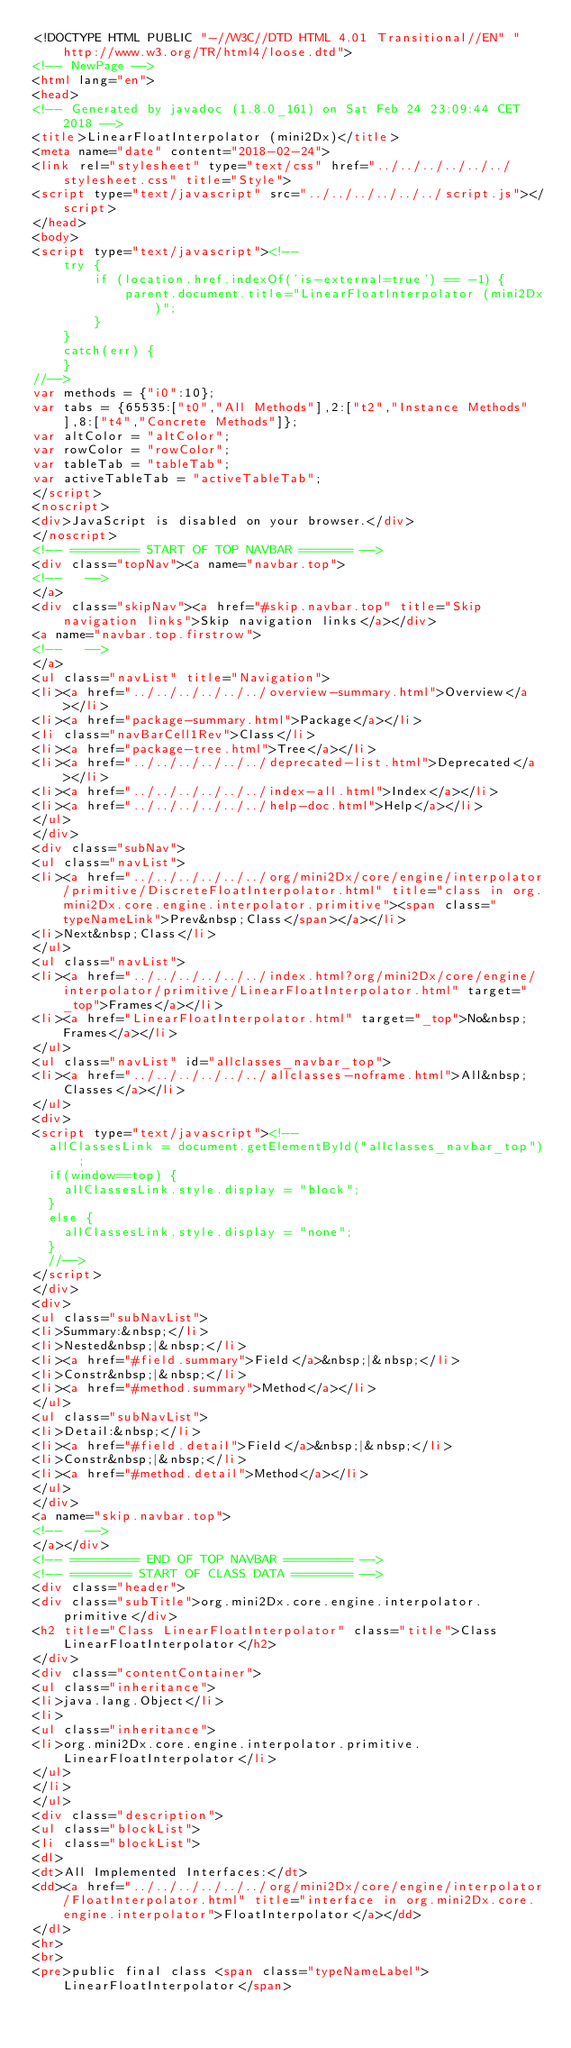<code> <loc_0><loc_0><loc_500><loc_500><_HTML_><!DOCTYPE HTML PUBLIC "-//W3C//DTD HTML 4.01 Transitional//EN" "http://www.w3.org/TR/html4/loose.dtd">
<!-- NewPage -->
<html lang="en">
<head>
<!-- Generated by javadoc (1.8.0_161) on Sat Feb 24 23:09:44 CET 2018 -->
<title>LinearFloatInterpolator (mini2Dx)</title>
<meta name="date" content="2018-02-24">
<link rel="stylesheet" type="text/css" href="../../../../../../stylesheet.css" title="Style">
<script type="text/javascript" src="../../../../../../script.js"></script>
</head>
<body>
<script type="text/javascript"><!--
    try {
        if (location.href.indexOf('is-external=true') == -1) {
            parent.document.title="LinearFloatInterpolator (mini2Dx)";
        }
    }
    catch(err) {
    }
//-->
var methods = {"i0":10};
var tabs = {65535:["t0","All Methods"],2:["t2","Instance Methods"],8:["t4","Concrete Methods"]};
var altColor = "altColor";
var rowColor = "rowColor";
var tableTab = "tableTab";
var activeTableTab = "activeTableTab";
</script>
<noscript>
<div>JavaScript is disabled on your browser.</div>
</noscript>
<!-- ========= START OF TOP NAVBAR ======= -->
<div class="topNav"><a name="navbar.top">
<!--   -->
</a>
<div class="skipNav"><a href="#skip.navbar.top" title="Skip navigation links">Skip navigation links</a></div>
<a name="navbar.top.firstrow">
<!--   -->
</a>
<ul class="navList" title="Navigation">
<li><a href="../../../../../../overview-summary.html">Overview</a></li>
<li><a href="package-summary.html">Package</a></li>
<li class="navBarCell1Rev">Class</li>
<li><a href="package-tree.html">Tree</a></li>
<li><a href="../../../../../../deprecated-list.html">Deprecated</a></li>
<li><a href="../../../../../../index-all.html">Index</a></li>
<li><a href="../../../../../../help-doc.html">Help</a></li>
</ul>
</div>
<div class="subNav">
<ul class="navList">
<li><a href="../../../../../../org/mini2Dx/core/engine/interpolator/primitive/DiscreteFloatInterpolator.html" title="class in org.mini2Dx.core.engine.interpolator.primitive"><span class="typeNameLink">Prev&nbsp;Class</span></a></li>
<li>Next&nbsp;Class</li>
</ul>
<ul class="navList">
<li><a href="../../../../../../index.html?org/mini2Dx/core/engine/interpolator/primitive/LinearFloatInterpolator.html" target="_top">Frames</a></li>
<li><a href="LinearFloatInterpolator.html" target="_top">No&nbsp;Frames</a></li>
</ul>
<ul class="navList" id="allclasses_navbar_top">
<li><a href="../../../../../../allclasses-noframe.html">All&nbsp;Classes</a></li>
</ul>
<div>
<script type="text/javascript"><!--
  allClassesLink = document.getElementById("allclasses_navbar_top");
  if(window==top) {
    allClassesLink.style.display = "block";
  }
  else {
    allClassesLink.style.display = "none";
  }
  //-->
</script>
</div>
<div>
<ul class="subNavList">
<li>Summary:&nbsp;</li>
<li>Nested&nbsp;|&nbsp;</li>
<li><a href="#field.summary">Field</a>&nbsp;|&nbsp;</li>
<li>Constr&nbsp;|&nbsp;</li>
<li><a href="#method.summary">Method</a></li>
</ul>
<ul class="subNavList">
<li>Detail:&nbsp;</li>
<li><a href="#field.detail">Field</a>&nbsp;|&nbsp;</li>
<li>Constr&nbsp;|&nbsp;</li>
<li><a href="#method.detail">Method</a></li>
</ul>
</div>
<a name="skip.navbar.top">
<!--   -->
</a></div>
<!-- ========= END OF TOP NAVBAR ========= -->
<!-- ======== START OF CLASS DATA ======== -->
<div class="header">
<div class="subTitle">org.mini2Dx.core.engine.interpolator.primitive</div>
<h2 title="Class LinearFloatInterpolator" class="title">Class LinearFloatInterpolator</h2>
</div>
<div class="contentContainer">
<ul class="inheritance">
<li>java.lang.Object</li>
<li>
<ul class="inheritance">
<li>org.mini2Dx.core.engine.interpolator.primitive.LinearFloatInterpolator</li>
</ul>
</li>
</ul>
<div class="description">
<ul class="blockList">
<li class="blockList">
<dl>
<dt>All Implemented Interfaces:</dt>
<dd><a href="../../../../../../org/mini2Dx/core/engine/interpolator/FloatInterpolator.html" title="interface in org.mini2Dx.core.engine.interpolator">FloatInterpolator</a></dd>
</dl>
<hr>
<br>
<pre>public final class <span class="typeNameLabel">LinearFloatInterpolator</span></code> 